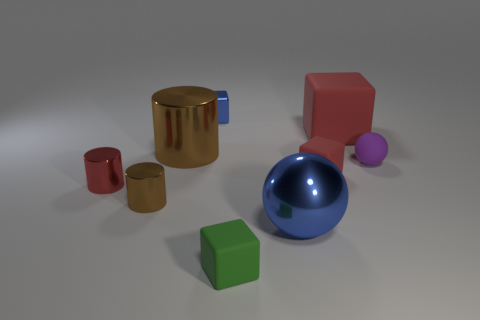Subtract all cylinders. How many objects are left? 6 Add 7 metallic cubes. How many metallic cubes exist? 8 Subtract 0 gray cubes. How many objects are left? 9 Subtract all red cylinders. Subtract all big brown metal cylinders. How many objects are left? 7 Add 3 big red rubber cubes. How many big red rubber cubes are left? 4 